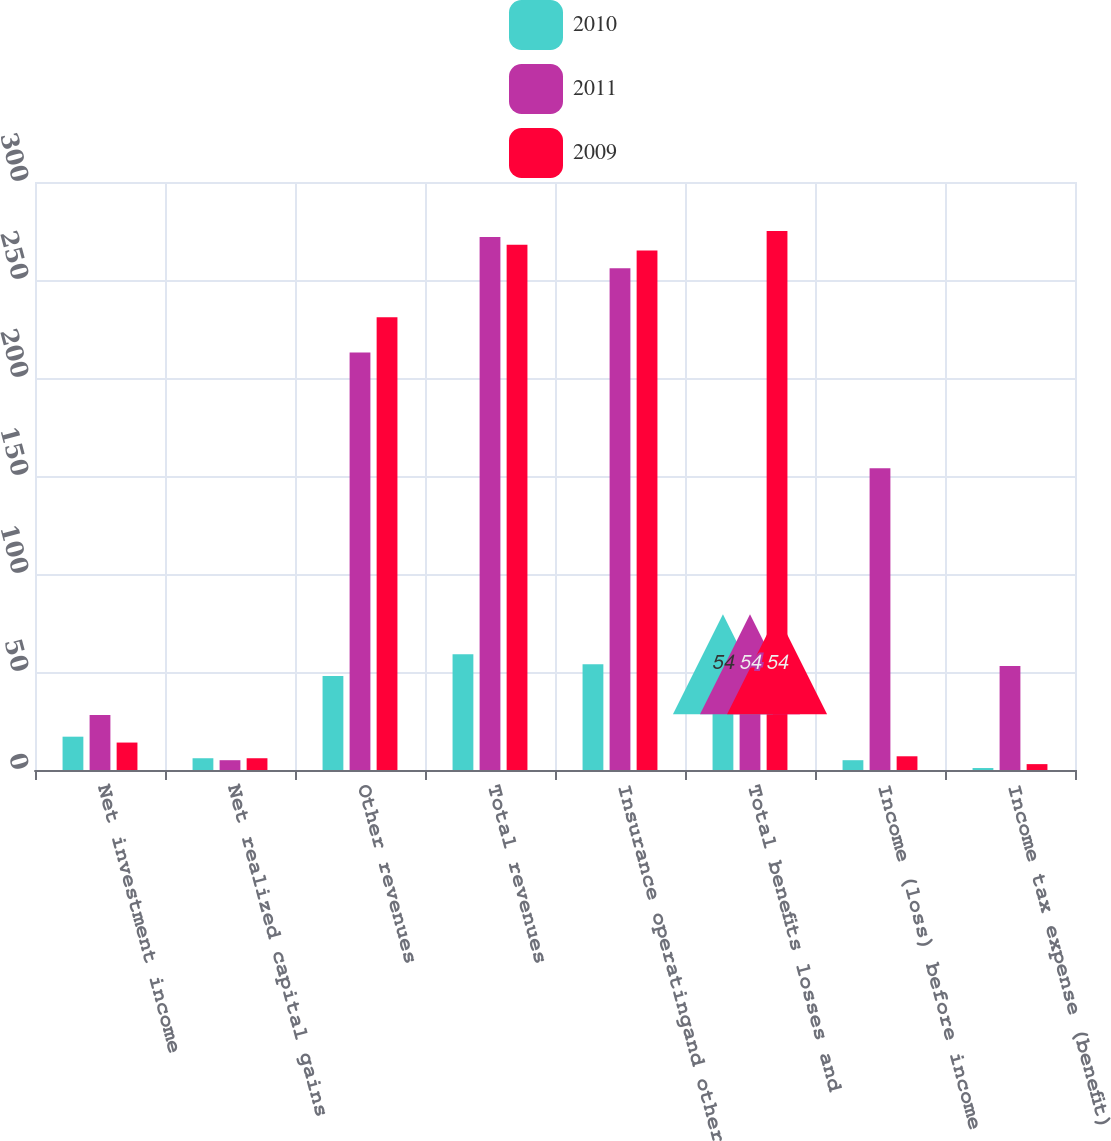<chart> <loc_0><loc_0><loc_500><loc_500><stacked_bar_chart><ecel><fcel>Net investment income<fcel>Net realized capital gains<fcel>Other revenues<fcel>Total revenues<fcel>Insurance operatingand other<fcel>Total benefits losses and<fcel>Income (loss) before income<fcel>Income tax expense (benefit)<nl><fcel>2010<fcel>17<fcel>6<fcel>48<fcel>59<fcel>54<fcel>54<fcel>5<fcel>1<nl><fcel>2011<fcel>28<fcel>5<fcel>213<fcel>272<fcel>256<fcel>53<fcel>154<fcel>53<nl><fcel>2009<fcel>14<fcel>6<fcel>231<fcel>268<fcel>265<fcel>275<fcel>7<fcel>3<nl></chart> 